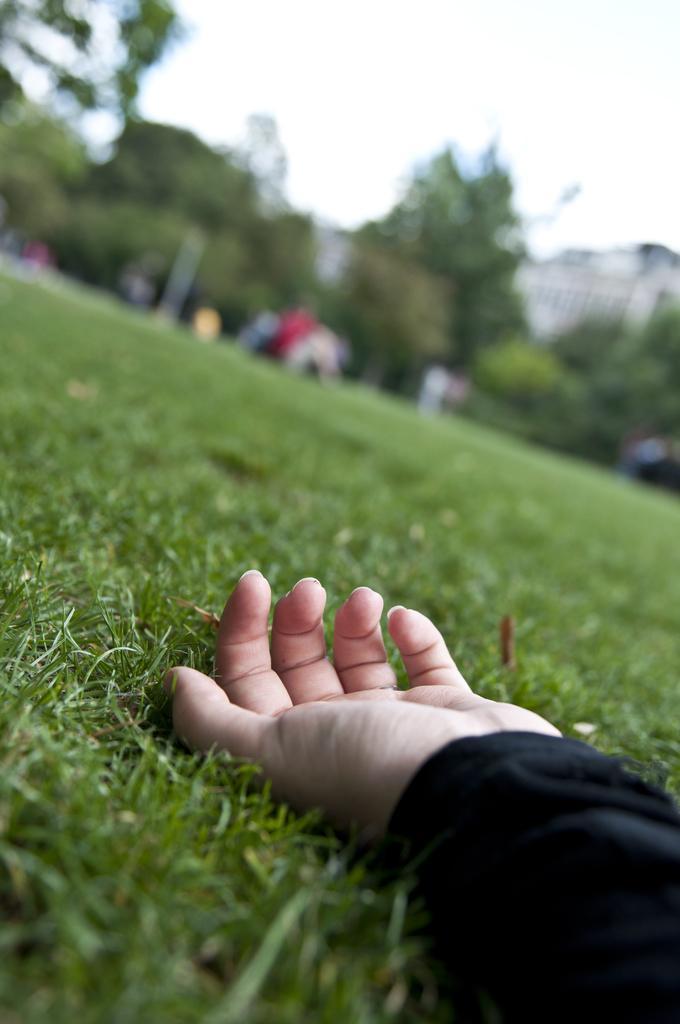In one or two sentences, can you explain what this image depicts? In this image we can see that there is a hand on the ground. In the background there are trees and buildings. On the ground there is grass. 